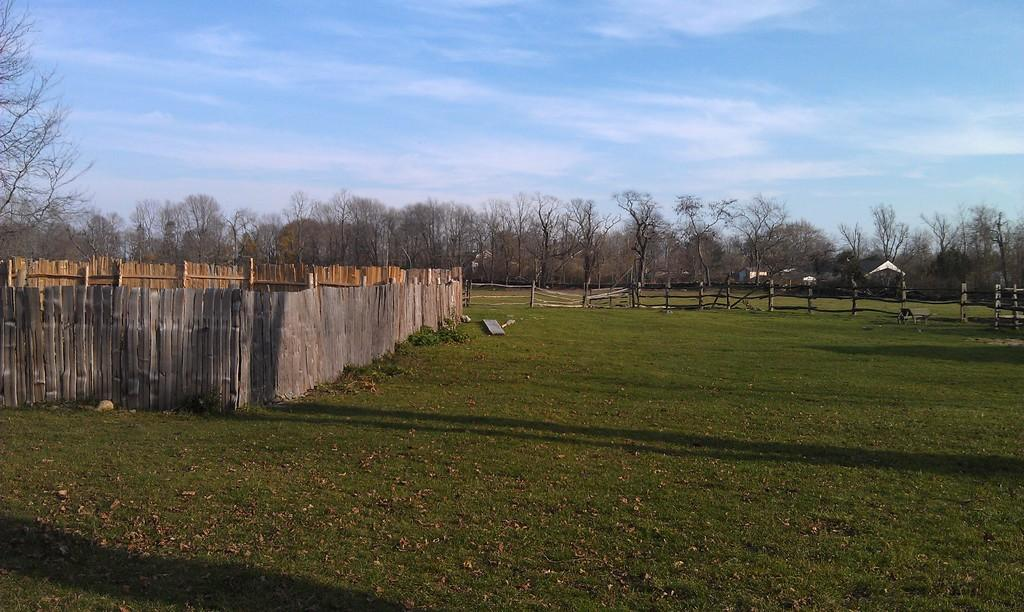What type of vegetation can be seen in the image? There is grass and dried leaves in the image. What type of fencing is present in the image? There is wooden fencing in the image. What other natural elements can be seen in the image? There are trees in the image. What is visible at the top of the image? The sky is visible at the top of the image. How many candles are on the birthday cake in the image? There is no birthday cake present in the image. What type of pan is used to cook the snakes in the image? There are no snakes or pans present in the image. 